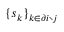Convert formula to latex. <formula><loc_0><loc_0><loc_500><loc_500>\{ s _ { k } \} _ { k \in \partial i \ j }</formula> 